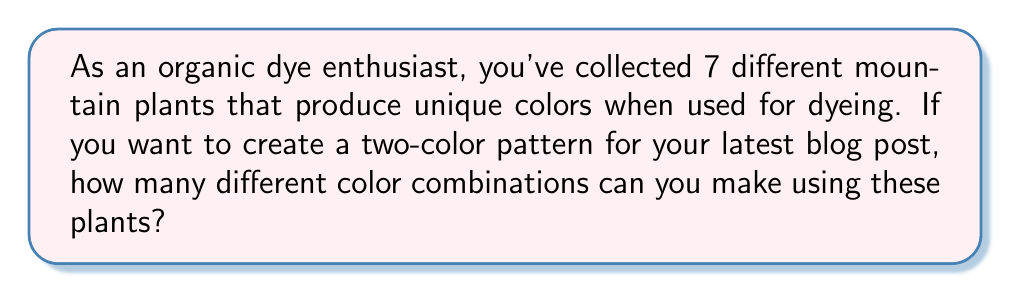Teach me how to tackle this problem. To solve this problem, we need to use the combination formula for selecting 2 items from a set of 7, without regard to order. This is because the order of colors doesn't matter in a two-color pattern (e.g., blue-green is the same as green-blue).

The formula for combinations is:

$$C(n,r) = \frac{n!}{r!(n-r)!}$$

Where:
$n$ is the total number of items (in this case, 7 plants)
$r$ is the number of items being chosen (in this case, 2 colors)

Plugging in our values:

$$C(7,2) = \frac{7!}{2!(7-2)!} = \frac{7!}{2!(5)!}$$

Expanding this:

$$\frac{7 \cdot 6 \cdot 5!}{2 \cdot 1 \cdot 5!}$$

The $5!$ cancels out in the numerator and denominator:

$$\frac{7 \cdot 6}{2 \cdot 1} = \frac{42}{2} = 21$$

Therefore, you can create 21 unique two-color combinations using your 7 mountain plants.
Answer: 21 combinations 